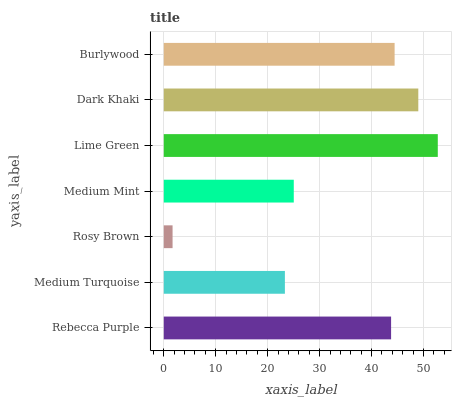Is Rosy Brown the minimum?
Answer yes or no. Yes. Is Lime Green the maximum?
Answer yes or no. Yes. Is Medium Turquoise the minimum?
Answer yes or no. No. Is Medium Turquoise the maximum?
Answer yes or no. No. Is Rebecca Purple greater than Medium Turquoise?
Answer yes or no. Yes. Is Medium Turquoise less than Rebecca Purple?
Answer yes or no. Yes. Is Medium Turquoise greater than Rebecca Purple?
Answer yes or no. No. Is Rebecca Purple less than Medium Turquoise?
Answer yes or no. No. Is Rebecca Purple the high median?
Answer yes or no. Yes. Is Rebecca Purple the low median?
Answer yes or no. Yes. Is Burlywood the high median?
Answer yes or no. No. Is Medium Mint the low median?
Answer yes or no. No. 